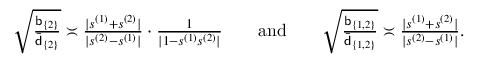Convert formula to latex. <formula><loc_0><loc_0><loc_500><loc_500>\begin{array} { r } { \sqrt { \frac { b _ { \{ 2 \} } } { \bar { d } _ { \{ 2 \} } } } \asymp \frac { | s ^ { ( 1 ) } + s ^ { ( 2 ) } | } { | s ^ { ( 2 ) } - s ^ { ( 1 ) } | } \cdot \frac { 1 } { | 1 - s ^ { ( 1 ) } s ^ { ( 2 ) } | } a n d \sqrt { \frac { b _ { \{ 1 , 2 \} } } { \bar { d } _ { \{ 1 , 2 \} } } } \asymp \frac { | s ^ { ( 1 ) } + s ^ { ( 2 ) } | } { | s ^ { ( 2 ) } - s ^ { ( 1 ) } | } . } \end{array}</formula> 